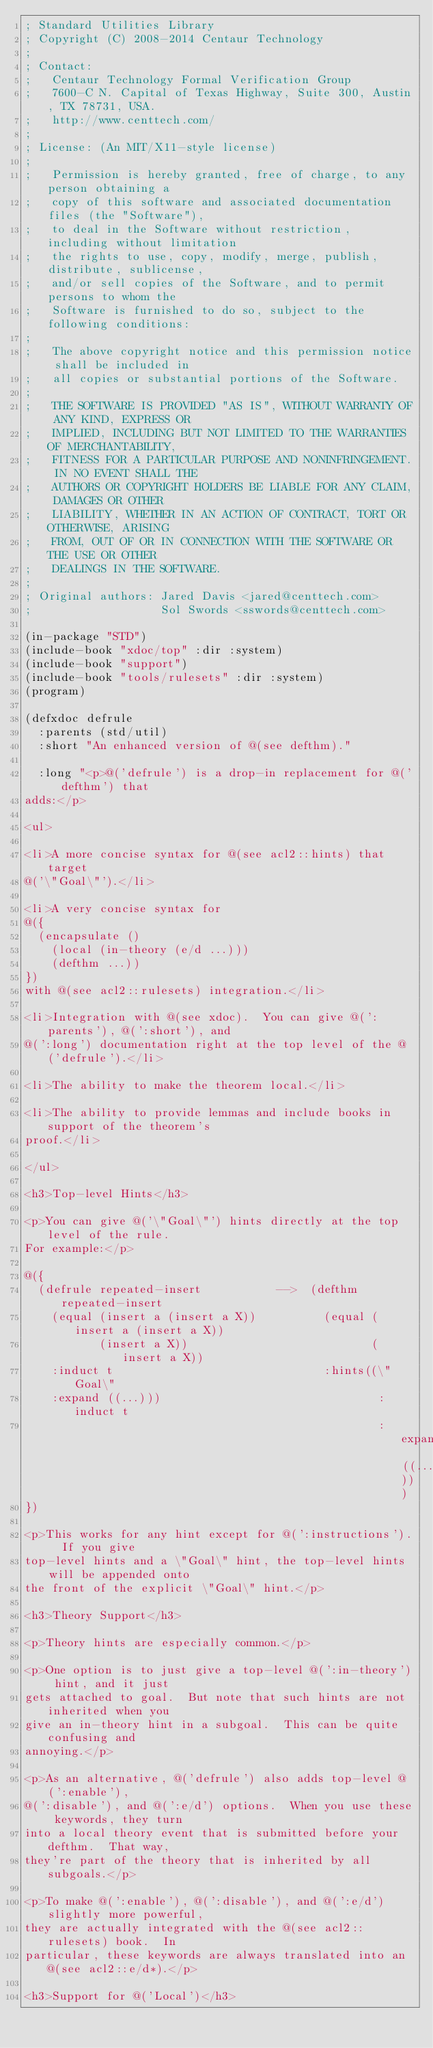Convert code to text. <code><loc_0><loc_0><loc_500><loc_500><_Lisp_>; Standard Utilities Library
; Copyright (C) 2008-2014 Centaur Technology
;
; Contact:
;   Centaur Technology Formal Verification Group
;   7600-C N. Capital of Texas Highway, Suite 300, Austin, TX 78731, USA.
;   http://www.centtech.com/
;
; License: (An MIT/X11-style license)
;
;   Permission is hereby granted, free of charge, to any person obtaining a
;   copy of this software and associated documentation files (the "Software"),
;   to deal in the Software without restriction, including without limitation
;   the rights to use, copy, modify, merge, publish, distribute, sublicense,
;   and/or sell copies of the Software, and to permit persons to whom the
;   Software is furnished to do so, subject to the following conditions:
;
;   The above copyright notice and this permission notice shall be included in
;   all copies or substantial portions of the Software.
;
;   THE SOFTWARE IS PROVIDED "AS IS", WITHOUT WARRANTY OF ANY KIND, EXPRESS OR
;   IMPLIED, INCLUDING BUT NOT LIMITED TO THE WARRANTIES OF MERCHANTABILITY,
;   FITNESS FOR A PARTICULAR PURPOSE AND NONINFRINGEMENT. IN NO EVENT SHALL THE
;   AUTHORS OR COPYRIGHT HOLDERS BE LIABLE FOR ANY CLAIM, DAMAGES OR OTHER
;   LIABILITY, WHETHER IN AN ACTION OF CONTRACT, TORT OR OTHERWISE, ARISING
;   FROM, OUT OF OR IN CONNECTION WITH THE SOFTWARE OR THE USE OR OTHER
;   DEALINGS IN THE SOFTWARE.
;
; Original authors: Jared Davis <jared@centtech.com>
;                   Sol Swords <sswords@centtech.com>

(in-package "STD")
(include-book "xdoc/top" :dir :system)
(include-book "support")
(include-book "tools/rulesets" :dir :system)
(program)

(defxdoc defrule
  :parents (std/util)
  :short "An enhanced version of @(see defthm)."

  :long "<p>@('defrule') is a drop-in replacement for @('defthm') that
adds:</p>

<ul>

<li>A more concise syntax for @(see acl2::hints) that target
@('\"Goal\"').</li>

<li>A very concise syntax for
@({
  (encapsulate ()
    (local (in-theory (e/d ...)))
    (defthm ...))
})
with @(see acl2::rulesets) integration.</li>

<li>Integration with @(see xdoc).  You can give @(':parents'), @(':short'), and
@(':long') documentation right at the top level of the @('defrule').</li>

<li>The ability to make the theorem local.</li>

<li>The ability to provide lemmas and include books in support of the theorem's
proof.</li>

</ul>

<h3>Top-level Hints</h3>

<p>You can give @('\"Goal\"') hints directly at the top level of the rule.
For example:</p>

@({
  (defrule repeated-insert           -->  (defthm repeated-insert
    (equal (insert a (insert a X))          (equal (insert a (insert a X))
           (insert a X))                           (insert a X))
    :induct t                               :hints((\"Goal\"
    :expand ((...)))                                :induct t
                                                    :expand ((...))))
})

<p>This works for any hint except for @(':instructions').  If you give
top-level hints and a \"Goal\" hint, the top-level hints will be appended onto
the front of the explicit \"Goal\" hint.</p>

<h3>Theory Support</h3>

<p>Theory hints are especially common.</p>

<p>One option is to just give a top-level @(':in-theory') hint, and it just
gets attached to goal.  But note that such hints are not inherited when you
give an in-theory hint in a subgoal.  This can be quite confusing and
annoying.</p>

<p>As an alternative, @('defrule') also adds top-level @(':enable'),
@(':disable'), and @(':e/d') options.  When you use these keywords, they turn
into a local theory event that is submitted before your defthm.  That way,
they're part of the theory that is inherited by all subgoals.</p>

<p>To make @(':enable'), @(':disable'), and @(':e/d') slightly more powerful,
they are actually integrated with the @(see acl2::rulesets) book.  In
particular, these keywords are always translated into an @(see acl2::e/d*).</p>

<h3>Support for @('Local')</h3>
</code> 